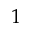Convert formula to latex. <formula><loc_0><loc_0><loc_500><loc_500>1</formula> 